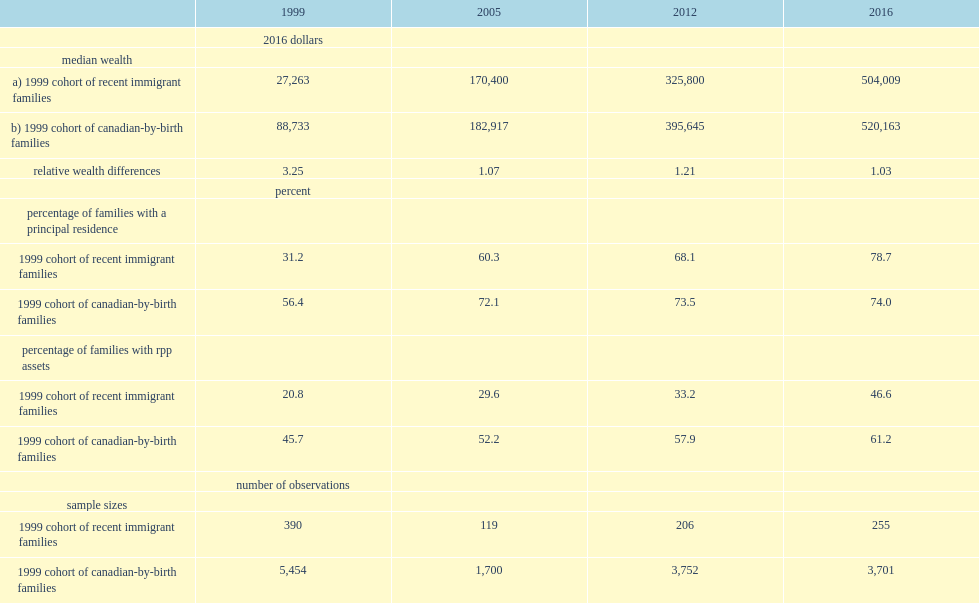How many times was the median wealth of the 1999 cohort of canadian-born families higher than that of the 1999 cohort of recent immigrant families in 2016? 1.03. How many times was the median wealth of the 1999 cohort of canadian-born families down from that of the 1999 cohort of recent immigrant families in 2016? 3.25. 